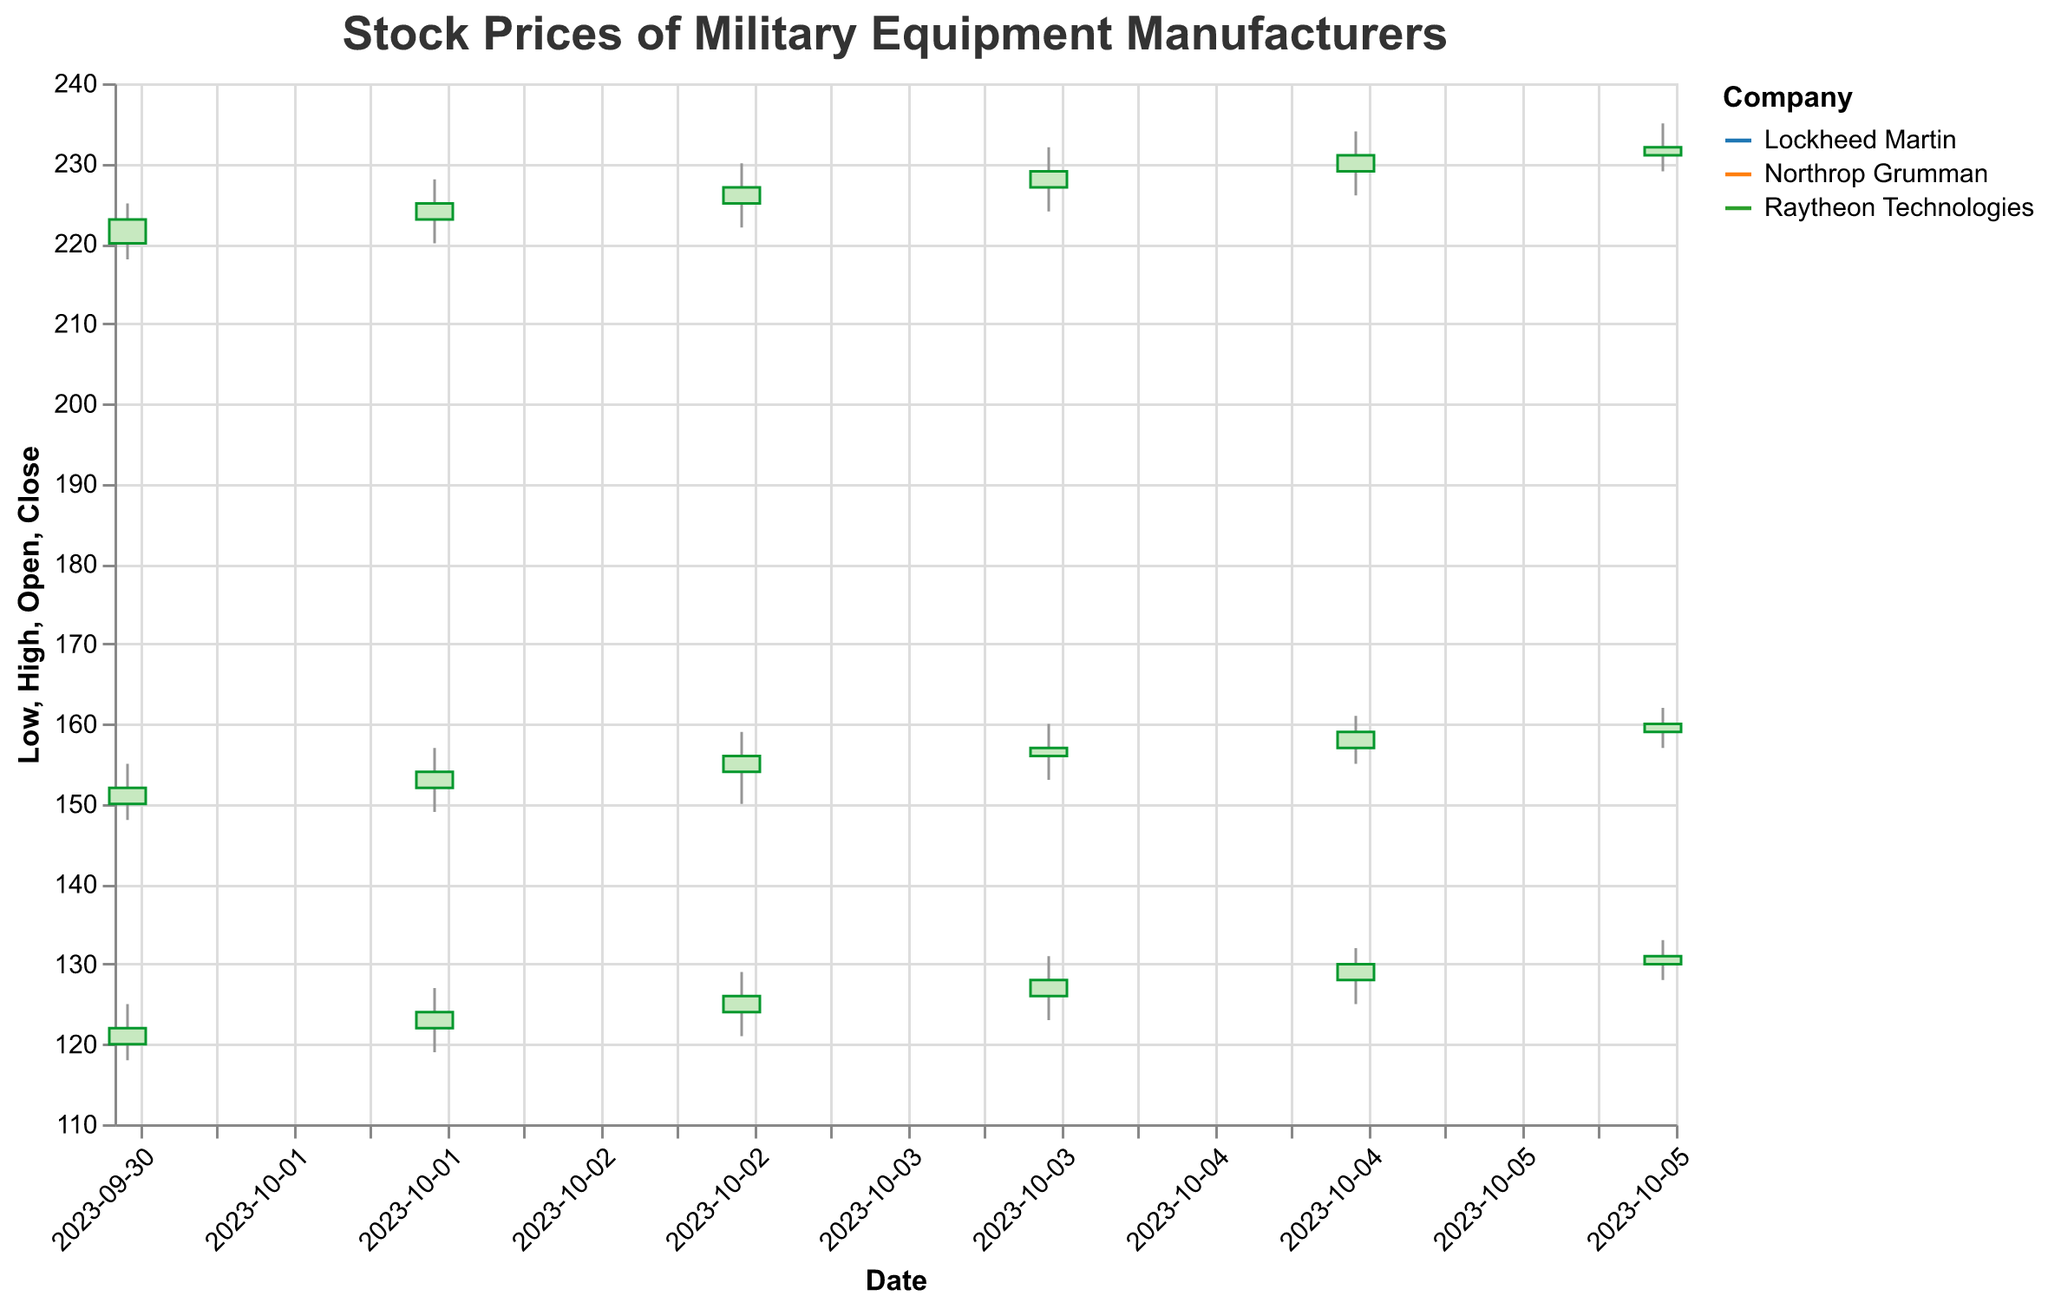What is the title of the figure? The title of the figure is displayed at the top of the plot. It reads "Stock Prices of Military Equipment Manufacturers" based on the title specified in the code.
Answer: Stock Prices of Military Equipment Manufacturers How many companies' stock prices are displayed in the figure? By looking at the color legend, which differentiates the companies, we see three companies: Lockheed Martin, Northrop Grumman, and Raytheon Technologies.
Answer: Three Which company had the highest stock price on October 2, 2023? To find this, we check the candlestick that represents October 2, 2023. We compare the highs for each company: Lockheed Martin (157), Northrop Grumman (127), Raytheon Technologies (228).
Answer: Raytheon Technologies On which date did Lockheed Martin have the highest closing price? We check the "Close" values for Lockheed Martin for each date: 152 on Oct 1, 154 on Oct 2, 156 on Oct 3, 157 on Oct 4 and 159 on Oct 5, 160 on Oct 6. The highest closing price is 160 on October 6.
Answer: October 6, 2023 Which day showed the largest difference between the high and low prices for Northrop Grumman? We calculate the difference between high and low for each date for Northrop Grumman and compare: Oct 1 (7), Oct 2 (8), Oct 3 (8), Oct 4 (8), Oct 5 (7), Oct 6 (5).
Answer: October 2, 2023 What was the overall trend for Raytheon Technologies' closing prices over the period? By following the closing prices for Raytheon Technologies from Oct 1 to Oct 6: 223, 225, 227, 229, 231, 232, we observe a consistent upward trend.
Answer: Upward trend Did any company experience a day where the closing price was lower than the opening price? For each company's daily data, we look for days where the close is lower than the open: None for Lockheed Martin, None for Northrop Grumman, None for Raytheon Technologies.
Answer: No On October 3, 2023, which company had the highest trading volume? Check the volume figures for Oct 3 for all companies: Lockheed Martin (1,300,000), Northrop Grumman (2,200,000), Raytheon Technologies (3,100,000).
Answer: Raytheon Technologies Comparing Lockheed Martin and Northrop Grumman, which had a greater increase in closing price from October 1 to October 6? Calculate the increase: Lockheed Martin (160 - 152 = 8), Northrop Grumman (131 - 122 = 9). Northrop Grumman had a greater increase.
Answer: Northrop Grumman What color is used to represent Raytheon Technologies in the figure? The color legends differentiate the companies. Raytheon Technologies is represented with the color that looks green.
Answer: Green 